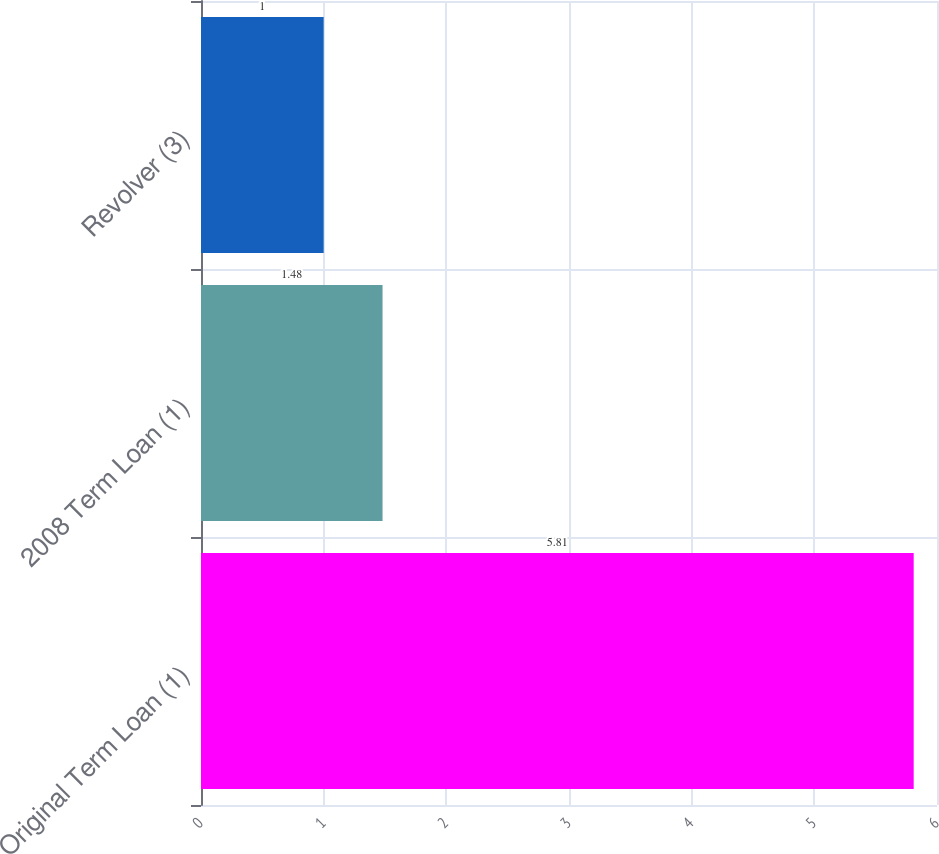Convert chart. <chart><loc_0><loc_0><loc_500><loc_500><bar_chart><fcel>Original Term Loan (1)<fcel>2008 Term Loan (1)<fcel>Revolver (3)<nl><fcel>5.81<fcel>1.48<fcel>1<nl></chart> 